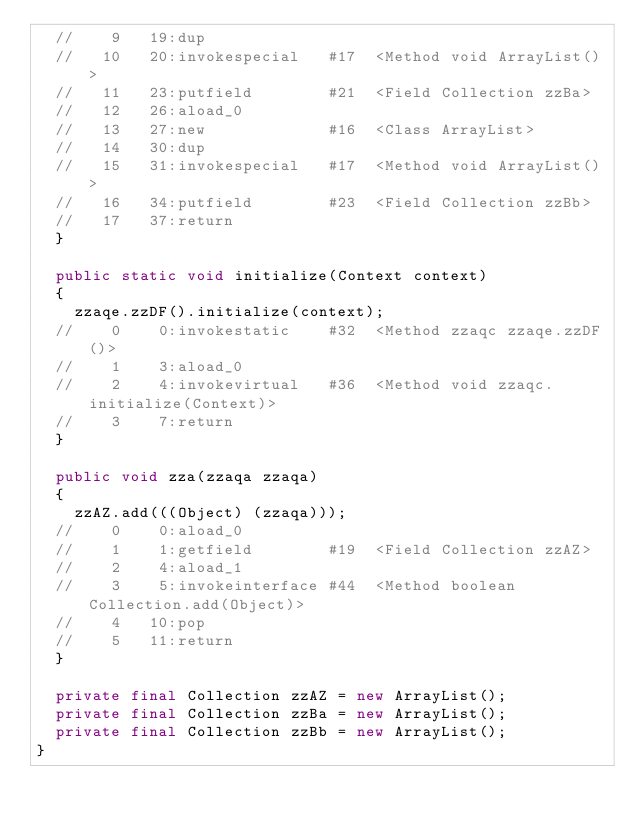<code> <loc_0><loc_0><loc_500><loc_500><_Java_>	//    9   19:dup             
	//   10   20:invokespecial   #17  <Method void ArrayList()>
	//   11   23:putfield        #21  <Field Collection zzBa>
	//   12   26:aload_0         
	//   13   27:new             #16  <Class ArrayList>
	//   14   30:dup             
	//   15   31:invokespecial   #17  <Method void ArrayList()>
	//   16   34:putfield        #23  <Field Collection zzBb>
	//   17   37:return          
	}

	public static void initialize(Context context)
	{
		zzaqe.zzDF().initialize(context);
	//    0    0:invokestatic    #32  <Method zzaqc zzaqe.zzDF()>
	//    1    3:aload_0         
	//    2    4:invokevirtual   #36  <Method void zzaqc.initialize(Context)>
	//    3    7:return          
	}

	public void zza(zzaqa zzaqa)
	{
		zzAZ.add(((Object) (zzaqa)));
	//    0    0:aload_0         
	//    1    1:getfield        #19  <Field Collection zzAZ>
	//    2    4:aload_1         
	//    3    5:invokeinterface #44  <Method boolean Collection.add(Object)>
	//    4   10:pop             
	//    5   11:return          
	}

	private final Collection zzAZ = new ArrayList();
	private final Collection zzBa = new ArrayList();
	private final Collection zzBb = new ArrayList();
}
</code> 